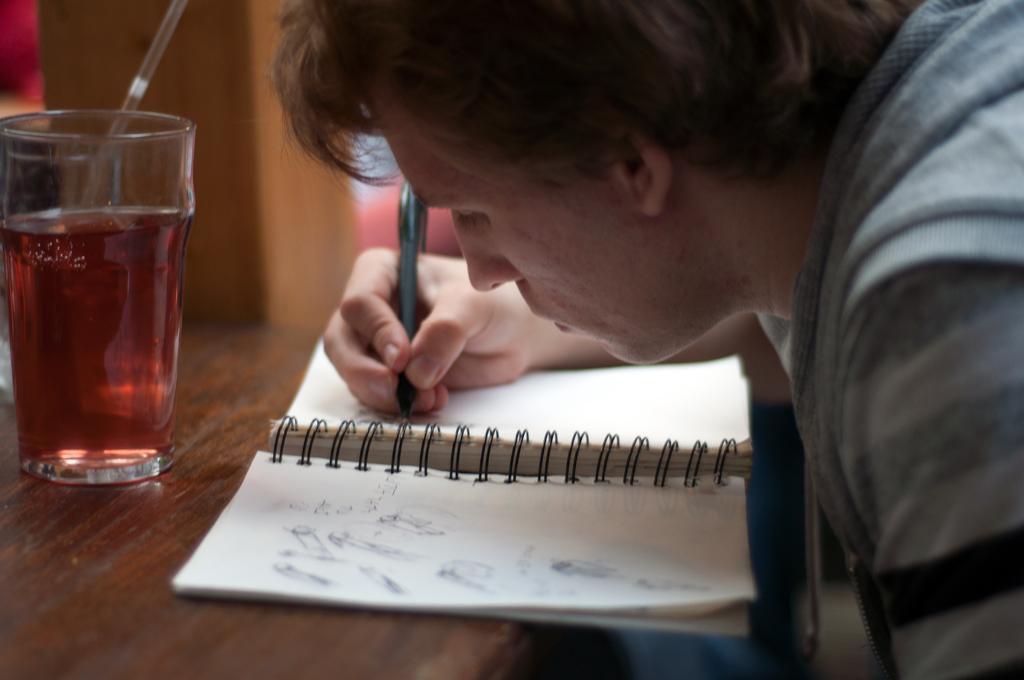Can you describe this image briefly? In this image we can see a man writing on the book which is placed on the table and there is a glass. In the background we can see a wall. 